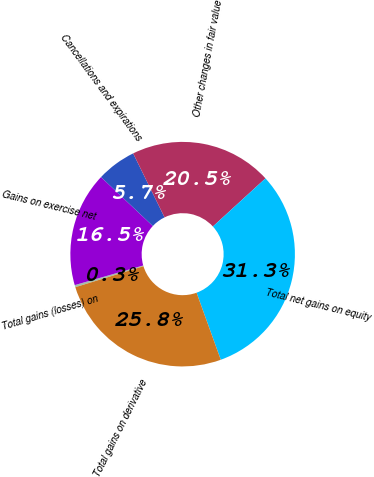Convert chart to OTSL. <chart><loc_0><loc_0><loc_500><loc_500><pie_chart><fcel>Total gains (losses) on<fcel>Gains on exercise net<fcel>Cancellations and expirations<fcel>Other changes in fair value<fcel>Total net gains on equity<fcel>Total gains on derivative<nl><fcel>0.31%<fcel>16.49%<fcel>5.69%<fcel>20.47%<fcel>31.28%<fcel>25.76%<nl></chart> 